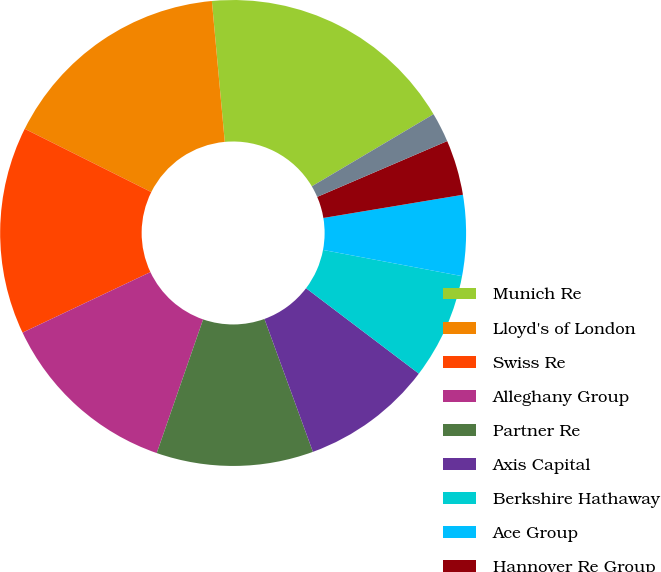<chart> <loc_0><loc_0><loc_500><loc_500><pie_chart><fcel>Munich Re<fcel>Lloyd's of London<fcel>Swiss Re<fcel>Alleghany Group<fcel>Partner Re<fcel>Axis Capital<fcel>Berkshire Hathaway<fcel>Ace Group<fcel>Hannover Re Group<fcel>Everest Re<nl><fcel>17.94%<fcel>16.17%<fcel>14.41%<fcel>12.65%<fcel>10.88%<fcel>9.12%<fcel>7.35%<fcel>5.59%<fcel>3.83%<fcel>2.06%<nl></chart> 